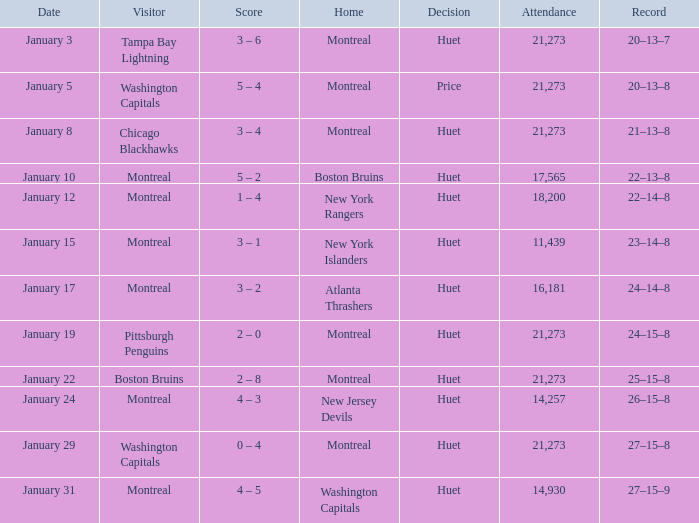What was the score of the game when the Boston Bruins were the visiting team? 2 – 8. 